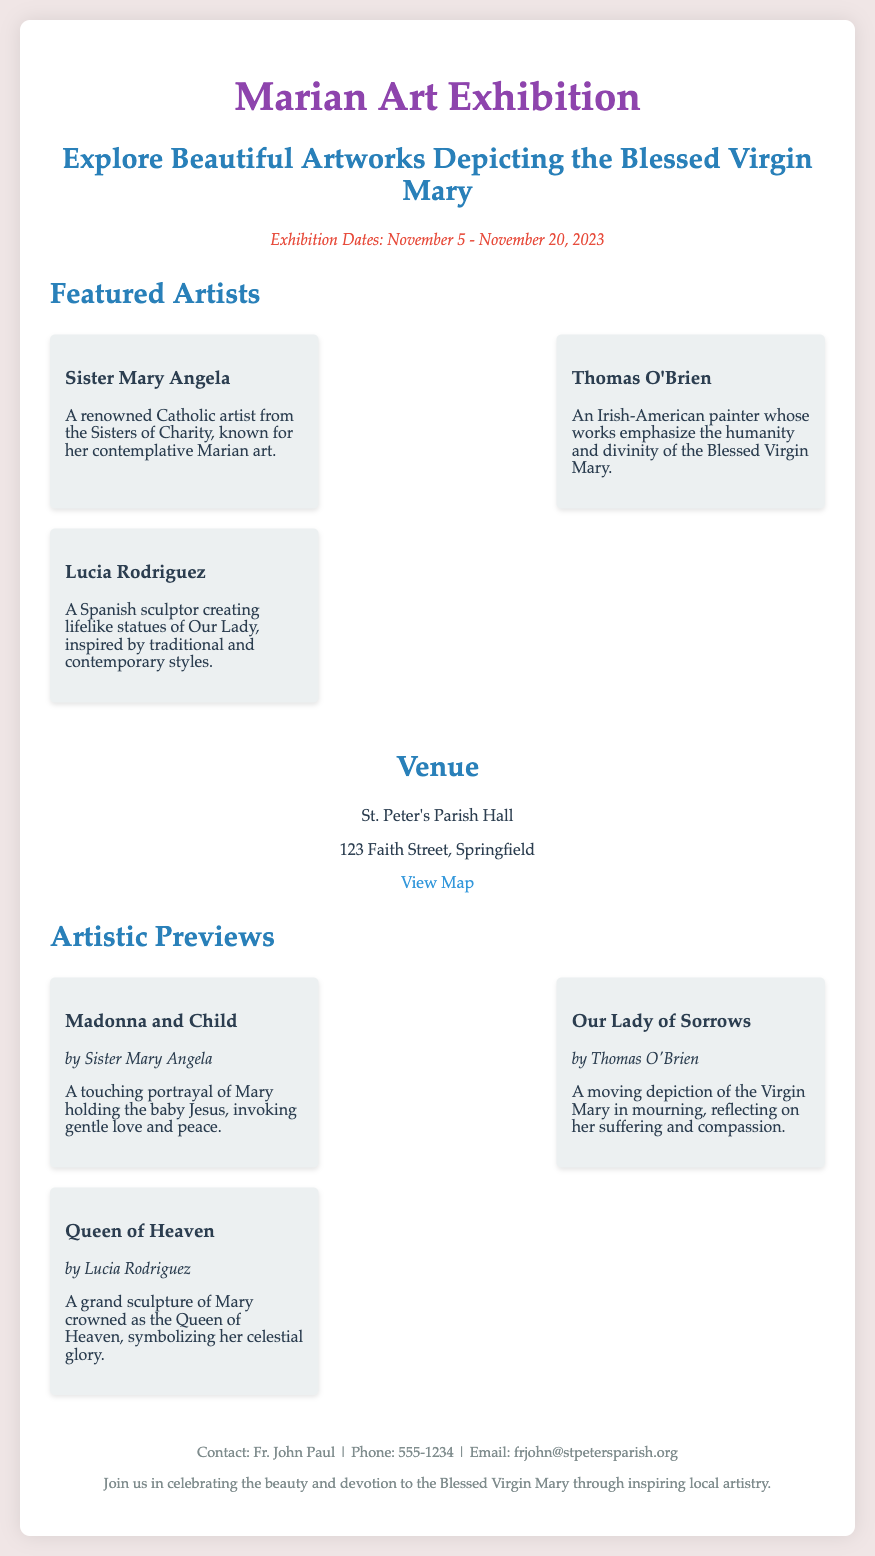What are the exhibition dates? The dates are provided in a specific section of the document, stating the exhibition period clearly.
Answer: November 5 - November 20, 2023 Who is the artist of "Madonna and Child"? This artwork is featured in the artistic previews section, along with its corresponding artist.
Answer: Sister Mary Angela Where is the exhibition being held? The venue address is mentioned in the venue section of the document.
Answer: St. Peter's Parish Hall Which artist created the sculpture "Queen of Heaven"? This information can be found with the artistic previews that list the title and artist of each artwork.
Answer: Lucia Rodriguez What is the contact email for Fr. John Paul? The contact information provided at the bottom of the document includes an email address.
Answer: frjohn@stpetersparish.org What is the focus of the artworks displayed? The exhibition is centered around a specific theme which is highlighted in the introduction section of the document.
Answer: The Blessed Virgin Mary How many featured artists are there? This can be calculated by counting the entries listed in the featured artists section.
Answer: Three What type of art does Thomas O'Brien emphasize? The description of Thomas O'Brien in the artists section reveals the focus of his artwork.
Answer: Humanity and divinity of the Blessed Virgin Mary 